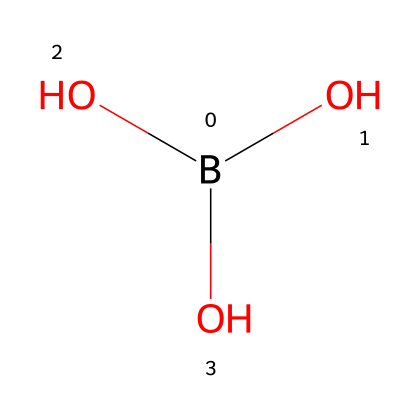What is the total number of oxygen atoms in this chemical? The SMILES representation shows the structure B(O)(O)O, which indicates that there are three hydroxyl groups (-OH) bonded to the boron atom, resulting in three oxygen atoms.
Answer: three What is the chemical name of this compound? The SMILES notation indicates the presence of boron and hydroxyl groups, which collectively is known as boric acid.
Answer: boric acid What is the oxidation state of boron in this chemical? In boric acid, boron (B) is bonded to three oxygen atoms, and typically in such compounds, boron has an oxidation state of +3.
Answer: +3 How many total atoms are in this chemical structure? The structure includes one boron atom and three oxygen atoms, making a total of four atoms (1 + 3 = 4).
Answer: four Is this chemical considered a weak or strong acid? Boric acid is known to be a weak acid as it does not completely dissociate in water.
Answer: weak acid What type of interactions does boric acid typically engage in? Boric acid often forms hydrogen bonds due to the presence of multiple hydroxyl groups, which are capable of donating hydrogen ions.
Answer: hydrogen bonds What is the primary use of this chemical in personal care products? Boric acid is primarily utilized as a mild antiseptic in various personal care products due to its antibacterial properties.
Answer: mild antiseptic 